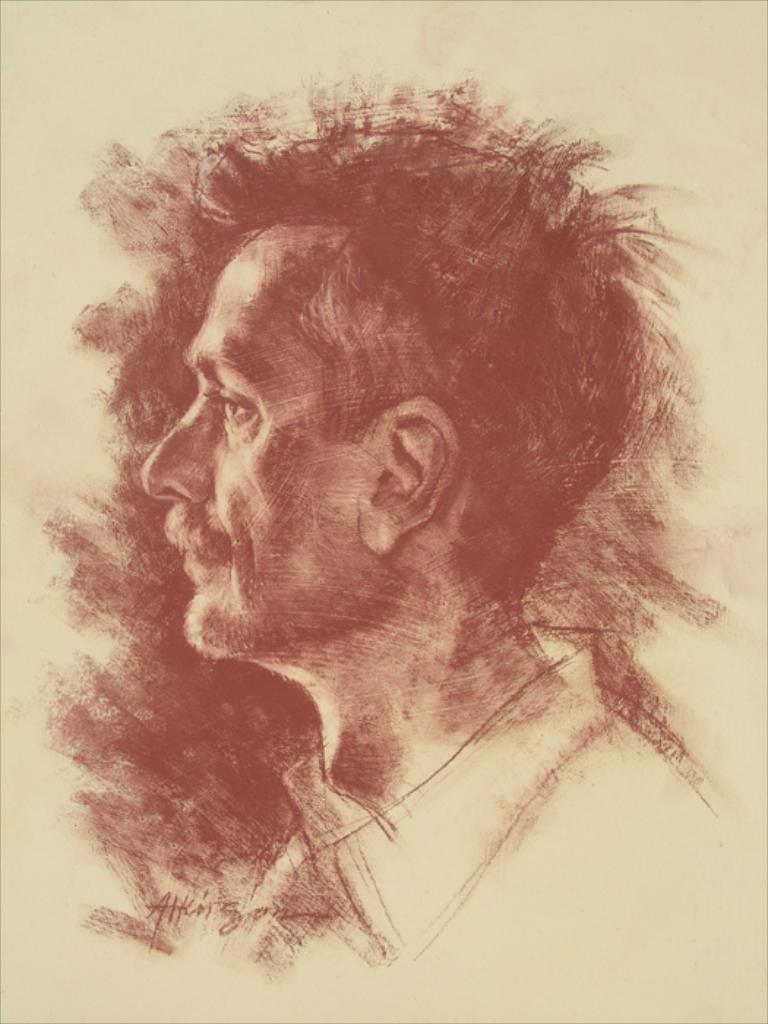In one or two sentences, can you explain what this image depicts? In this image we can see drawing of a man. 